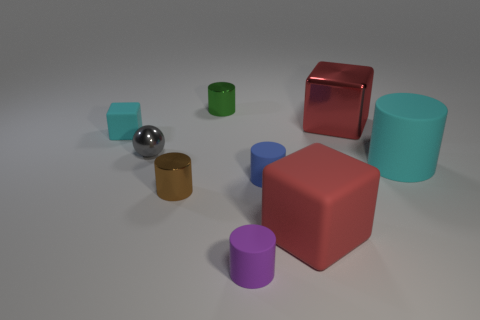What might be the purpose of these objects in the context they are presented? The arrangement and variety of geometric shapes suggest this might be a setup for an educational purpose, possibly illustrating shapes and colors for a learning module or a graphical representation in a design concept. The array and size differences could also provide a visual aid for explaining perspective, light, and shadow in a photography or art class. 